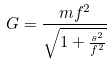<formula> <loc_0><loc_0><loc_500><loc_500>G = \frac { m f ^ { 2 } } { \sqrt { 1 + \frac { s ^ { 2 } } { f ^ { 2 } } } }</formula> 